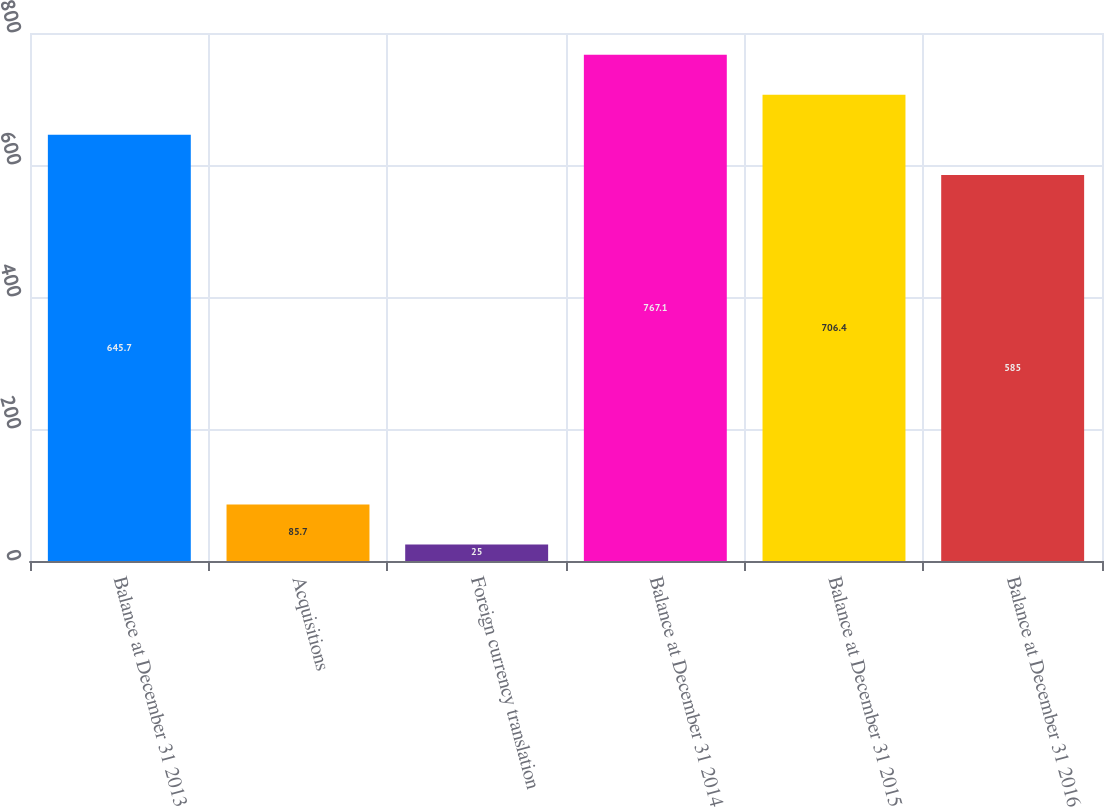Convert chart. <chart><loc_0><loc_0><loc_500><loc_500><bar_chart><fcel>Balance at December 31 2013<fcel>Acquisitions<fcel>Foreign currency translation<fcel>Balance at December 31 2014<fcel>Balance at December 31 2015<fcel>Balance at December 31 2016<nl><fcel>645.7<fcel>85.7<fcel>25<fcel>767.1<fcel>706.4<fcel>585<nl></chart> 